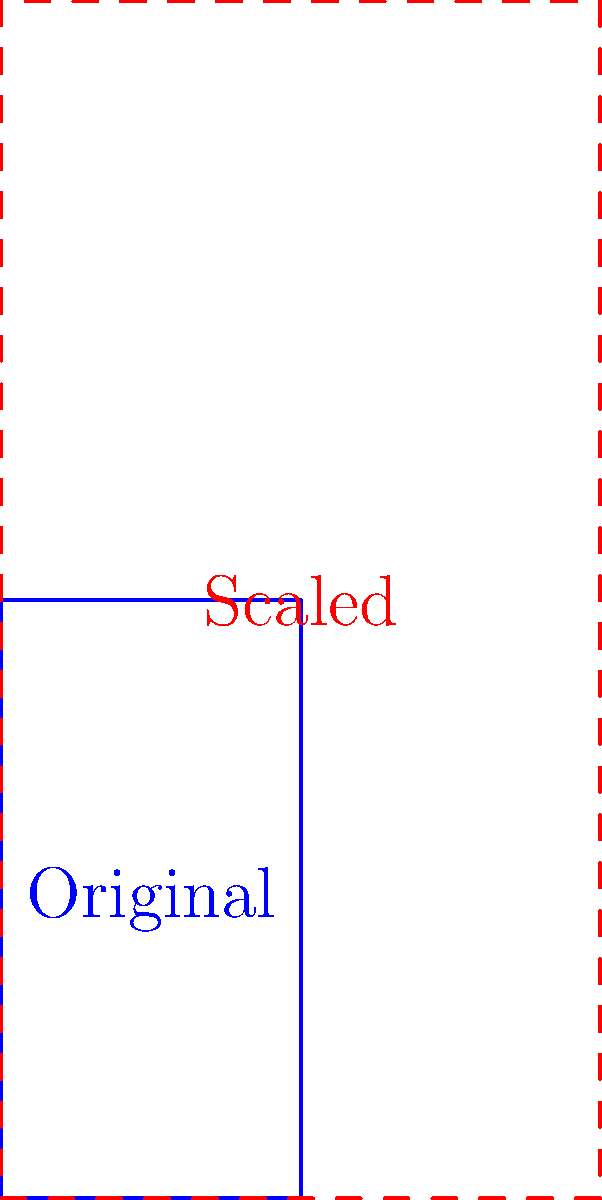The iconic Linkin Park logo needs to be scaled up for a large banner at a tribute concert for Chester Bennington. If the original logo is represented by the vector $\mathbf{v} = \begin{pmatrix} 1 \\ 2 \end{pmatrix}$, and you need to double its size while maintaining its proportions, what scalar multiplication should be applied to $\mathbf{v}$? To scale a vector while maintaining its proportions, we need to multiply it by a scalar. Let's approach this step-by-step:

1) The original vector is $\mathbf{v} = \begin{pmatrix} 1 \\ 2 \end{pmatrix}$.

2) We want to double the size of the logo, which means we need to double both dimensions.

3) To achieve this, we multiply the vector by a scalar $k = 2$:

   $k\mathbf{v} = 2\begin{pmatrix} 1 \\ 2 \end{pmatrix} = \begin{pmatrix} 2 \\ 4 \end{pmatrix}$

4) This new vector $\begin{pmatrix} 2 \\ 4 \end{pmatrix}$ represents the scaled logo.

5) We can verify that the proportions are maintained:
   Original ratio: $\frac{2}{1} = 2$
   New ratio: $\frac{4}{2} = 2$

Therefore, to double the size of the Linkin Park logo while maintaining its proportions, we need to multiply the original vector by the scalar 2.
Answer: $2\mathbf{v}$ 